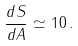<formula> <loc_0><loc_0><loc_500><loc_500>\frac { d S } { d A } \simeq 1 0 \, .</formula> 